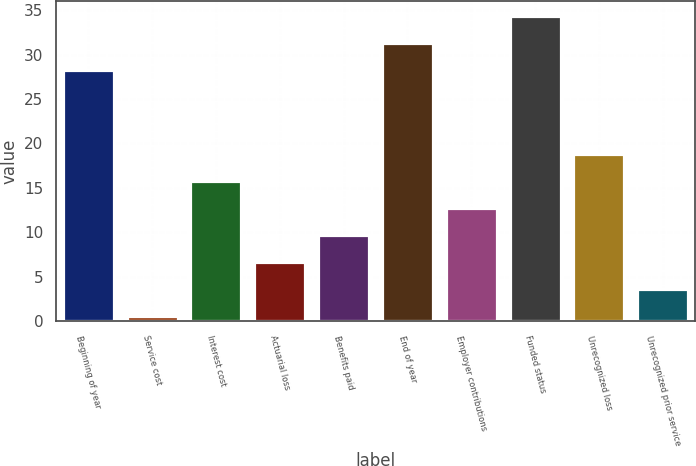<chart> <loc_0><loc_0><loc_500><loc_500><bar_chart><fcel>Beginning of year<fcel>Service cost<fcel>Interest cost<fcel>Actuarial loss<fcel>Benefits paid<fcel>End of year<fcel>Employer contributions<fcel>Funded status<fcel>Unrecognized loss<fcel>Unrecognized prior service<nl><fcel>28.3<fcel>0.6<fcel>15.75<fcel>6.66<fcel>9.69<fcel>31.33<fcel>12.72<fcel>34.36<fcel>18.78<fcel>3.63<nl></chart> 